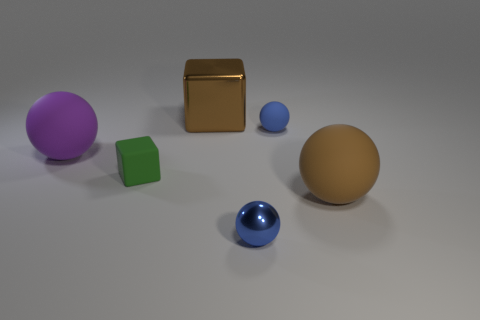Are there more metal things that are to the left of the tiny blue metallic sphere than big blue objects?
Your answer should be very brief. Yes. There is a thing that is behind the tiny green object and to the left of the brown cube; how big is it?
Offer a very short reply. Large. There is a purple thing that is the same shape as the brown matte thing; what material is it?
Ensure brevity in your answer.  Rubber. There is a brown object left of the blue matte object; is it the same size as the green thing?
Provide a short and direct response. No. The object that is to the right of the small metallic sphere and in front of the green matte cube is what color?
Make the answer very short. Brown. What number of blue matte objects are to the left of the matte thing in front of the green matte block?
Your answer should be compact. 1. Does the tiny blue matte object have the same shape as the green matte thing?
Make the answer very short. No. Is there anything else that has the same color as the big metal thing?
Provide a succinct answer. Yes. There is a small blue rubber object; is it the same shape as the metallic thing that is in front of the brown metallic thing?
Provide a short and direct response. Yes. What is the color of the rubber object in front of the cube that is in front of the big sphere that is behind the brown matte sphere?
Your response must be concise. Brown. 